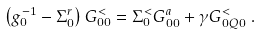Convert formula to latex. <formula><loc_0><loc_0><loc_500><loc_500>\left ( g ^ { - 1 } _ { 0 } - \Sigma ^ { r } _ { 0 } \right ) G ^ { < } _ { 0 0 } & = \Sigma ^ { < } _ { 0 } G ^ { a } _ { 0 0 } + \gamma G ^ { < } _ { 0 Q 0 } \ .</formula> 